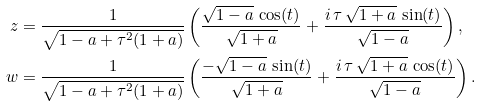<formula> <loc_0><loc_0><loc_500><loc_500>z & = \frac { 1 } { \sqrt { 1 - a + \tau ^ { 2 } ( 1 + a ) } } \left ( \frac { \sqrt { 1 - a } \, \cos ( t ) } { \sqrt { 1 + a } } + \frac { i \, \tau \, \sqrt { 1 + a } \, \sin ( t ) } { \sqrt { 1 - a } } \right ) , \\ w & = \frac { 1 } { \sqrt { 1 - a + \tau ^ { 2 } ( 1 + a ) } } \left ( \frac { - \sqrt { 1 - a } \, \sin ( t ) } { \sqrt { 1 + a } } + \frac { i \, \tau \, \sqrt { 1 + a } \, \cos ( t ) } { \sqrt { 1 - a } } \right ) .</formula> 